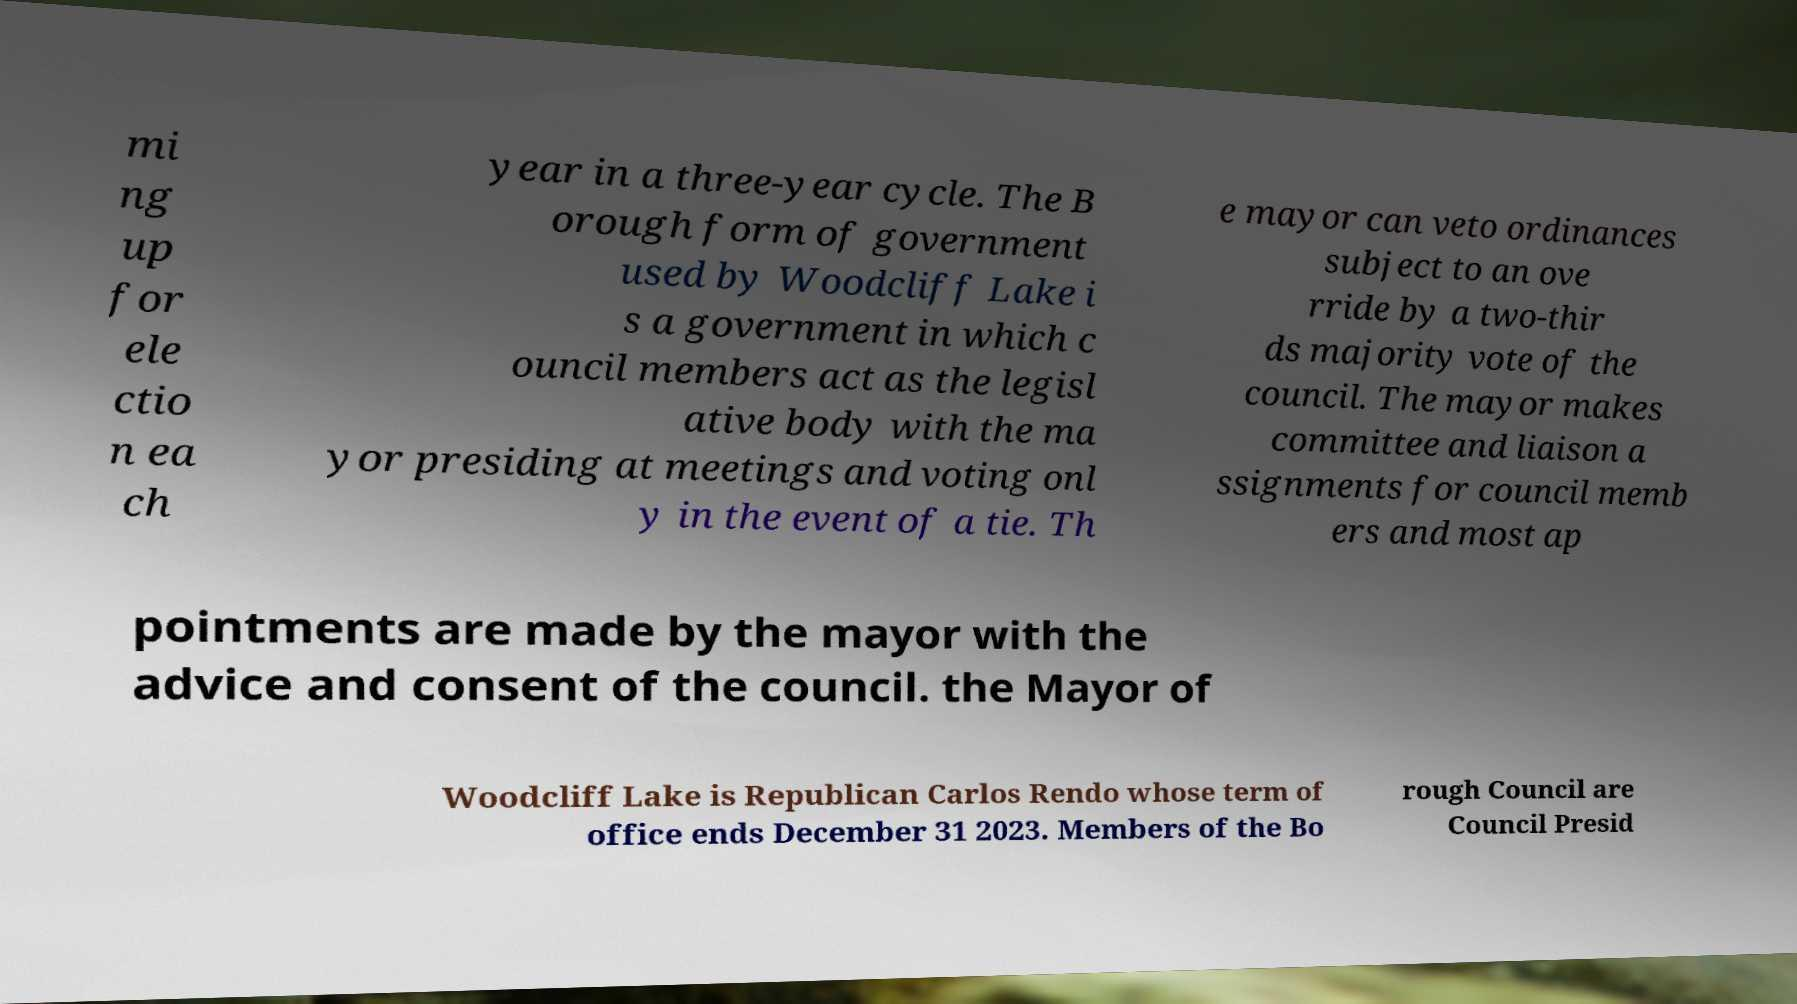For documentation purposes, I need the text within this image transcribed. Could you provide that? mi ng up for ele ctio n ea ch year in a three-year cycle. The B orough form of government used by Woodcliff Lake i s a government in which c ouncil members act as the legisl ative body with the ma yor presiding at meetings and voting onl y in the event of a tie. Th e mayor can veto ordinances subject to an ove rride by a two-thir ds majority vote of the council. The mayor makes committee and liaison a ssignments for council memb ers and most ap pointments are made by the mayor with the advice and consent of the council. the Mayor of Woodcliff Lake is Republican Carlos Rendo whose term of office ends December 31 2023. Members of the Bo rough Council are Council Presid 